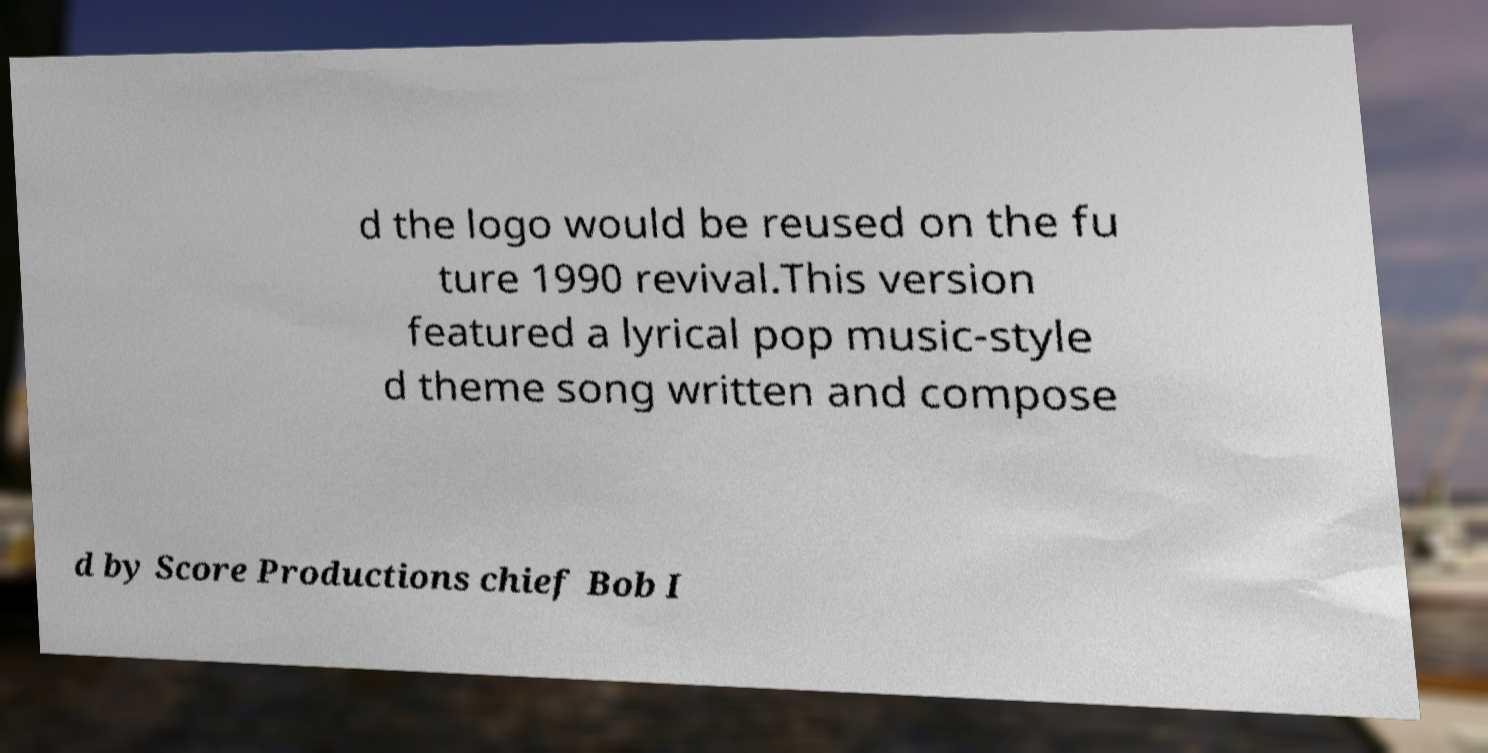Could you extract and type out the text from this image? d the logo would be reused on the fu ture 1990 revival.This version featured a lyrical pop music-style d theme song written and compose d by Score Productions chief Bob I 